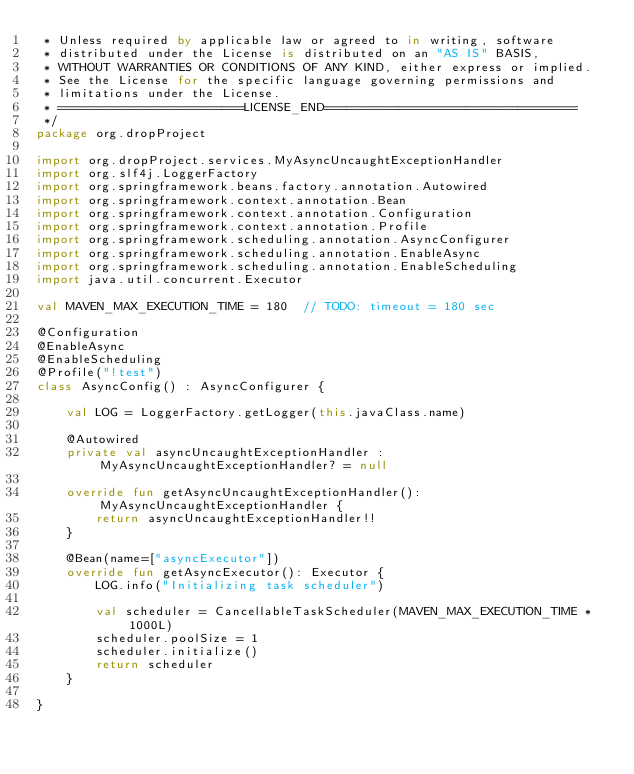Convert code to text. <code><loc_0><loc_0><loc_500><loc_500><_Kotlin_> * Unless required by applicable law or agreed to in writing, software
 * distributed under the License is distributed on an "AS IS" BASIS,
 * WITHOUT WARRANTIES OR CONDITIONS OF ANY KIND, either express or implied.
 * See the License for the specific language governing permissions and
 * limitations under the License.
 * =========================LICENSE_END==================================
 */
package org.dropProject

import org.dropProject.services.MyAsyncUncaughtExceptionHandler
import org.slf4j.LoggerFactory
import org.springframework.beans.factory.annotation.Autowired
import org.springframework.context.annotation.Bean
import org.springframework.context.annotation.Configuration
import org.springframework.context.annotation.Profile
import org.springframework.scheduling.annotation.AsyncConfigurer
import org.springframework.scheduling.annotation.EnableAsync
import org.springframework.scheduling.annotation.EnableScheduling
import java.util.concurrent.Executor

val MAVEN_MAX_EXECUTION_TIME = 180  // TODO: timeout = 180 sec

@Configuration
@EnableAsync
@EnableScheduling
@Profile("!test")
class AsyncConfig() : AsyncConfigurer {

    val LOG = LoggerFactory.getLogger(this.javaClass.name)

    @Autowired
    private val asyncUncaughtExceptionHandler : MyAsyncUncaughtExceptionHandler? = null

    override fun getAsyncUncaughtExceptionHandler(): MyAsyncUncaughtExceptionHandler {
        return asyncUncaughtExceptionHandler!!
    }

    @Bean(name=["asyncExecutor"])
    override fun getAsyncExecutor(): Executor {
        LOG.info("Initializing task scheduler")

        val scheduler = CancellableTaskScheduler(MAVEN_MAX_EXECUTION_TIME * 1000L)
        scheduler.poolSize = 1
        scheduler.initialize()
        return scheduler
    }

}
</code> 